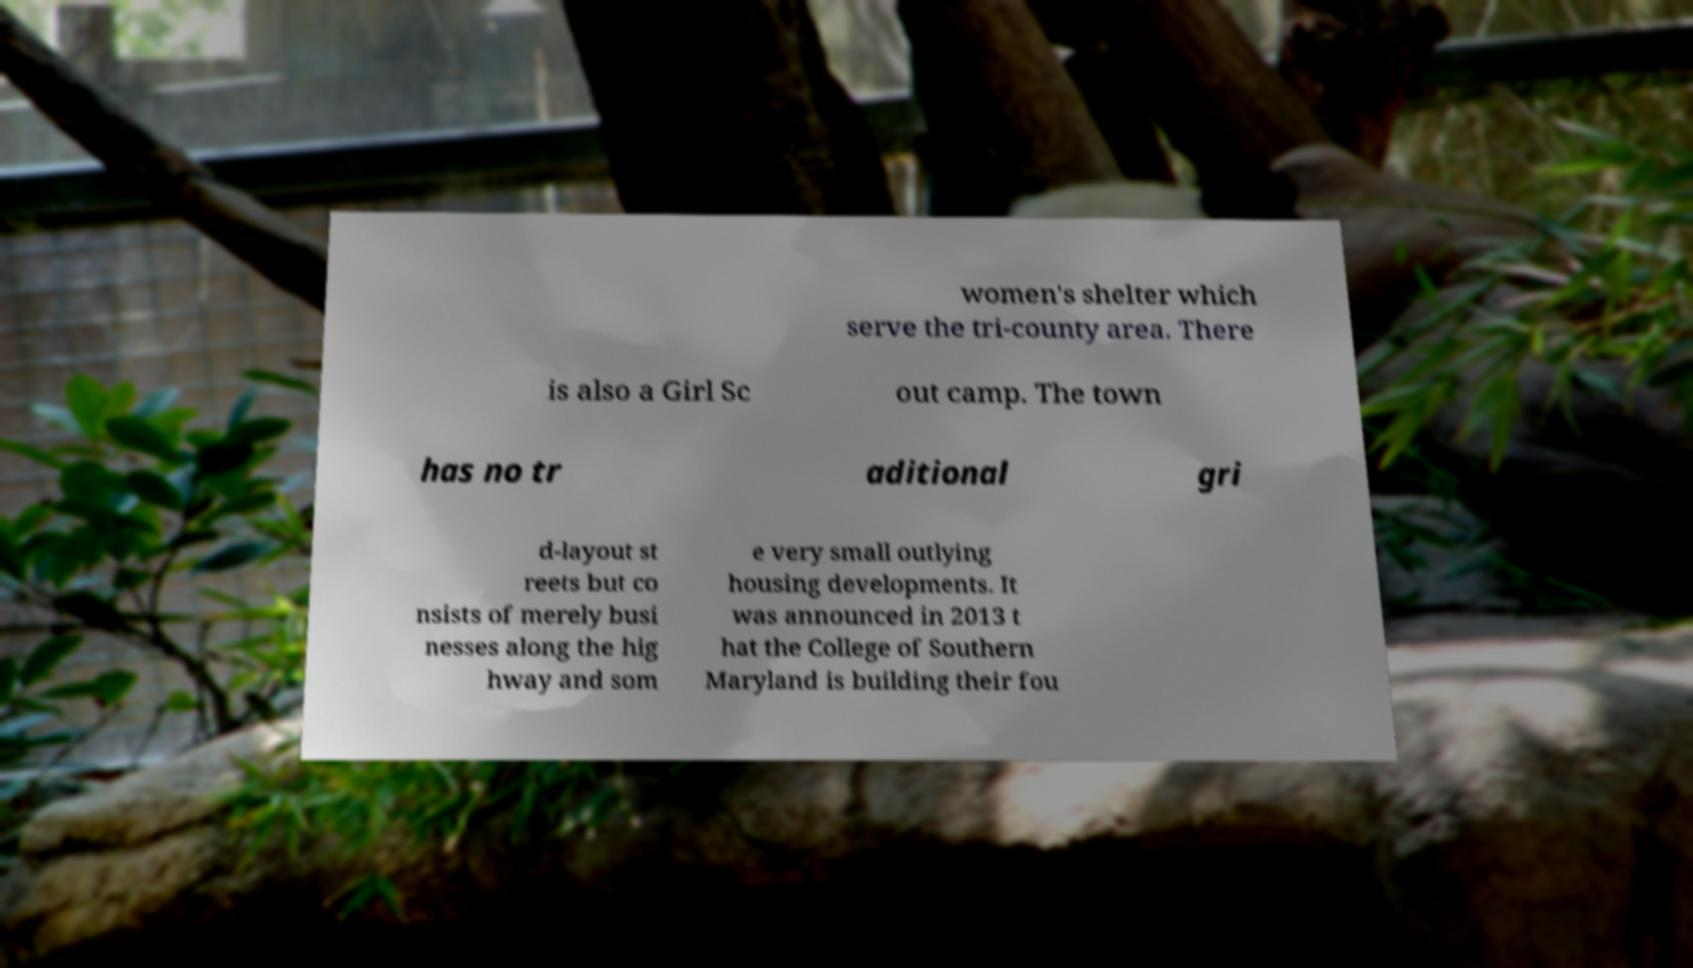Please read and relay the text visible in this image. What does it say? women's shelter which serve the tri-county area. There is also a Girl Sc out camp. The town has no tr aditional gri d-layout st reets but co nsists of merely busi nesses along the hig hway and som e very small outlying housing developments. It was announced in 2013 t hat the College of Southern Maryland is building their fou 